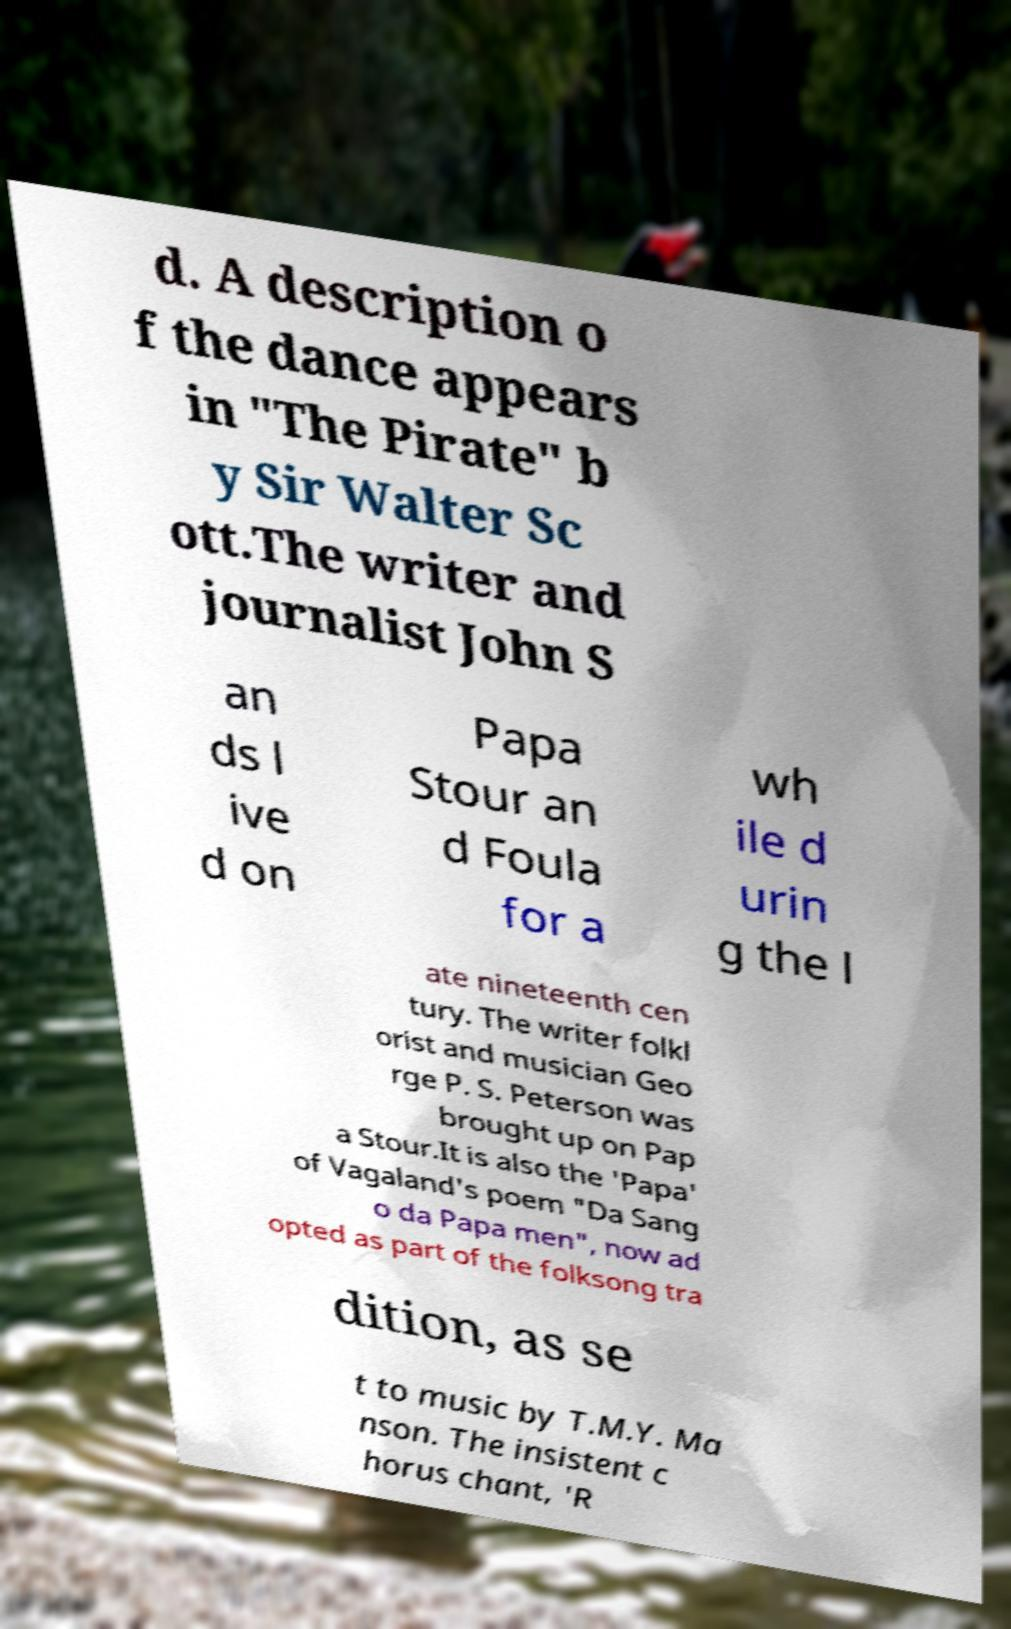Could you assist in decoding the text presented in this image and type it out clearly? d. A description o f the dance appears in "The Pirate" b y Sir Walter Sc ott.The writer and journalist John S an ds l ive d on Papa Stour an d Foula for a wh ile d urin g the l ate nineteenth cen tury. The writer folkl orist and musician Geo rge P. S. Peterson was brought up on Pap a Stour.It is also the 'Papa' of Vagaland's poem "Da Sang o da Papa men", now ad opted as part of the folksong tra dition, as se t to music by T.M.Y. Ma nson. The insistent c horus chant, 'R 